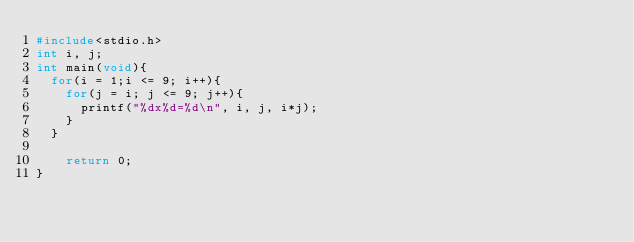Convert code to text. <code><loc_0><loc_0><loc_500><loc_500><_C_>#include<stdio.h>
int i, j;
int main(void){
  for(i = 1;i <= 9; i++){
    for(j = i; j <= 9; j++){
      printf("%dx%d=%d\n", i, j, i*j);
    }
  }

    return 0;
}</code> 